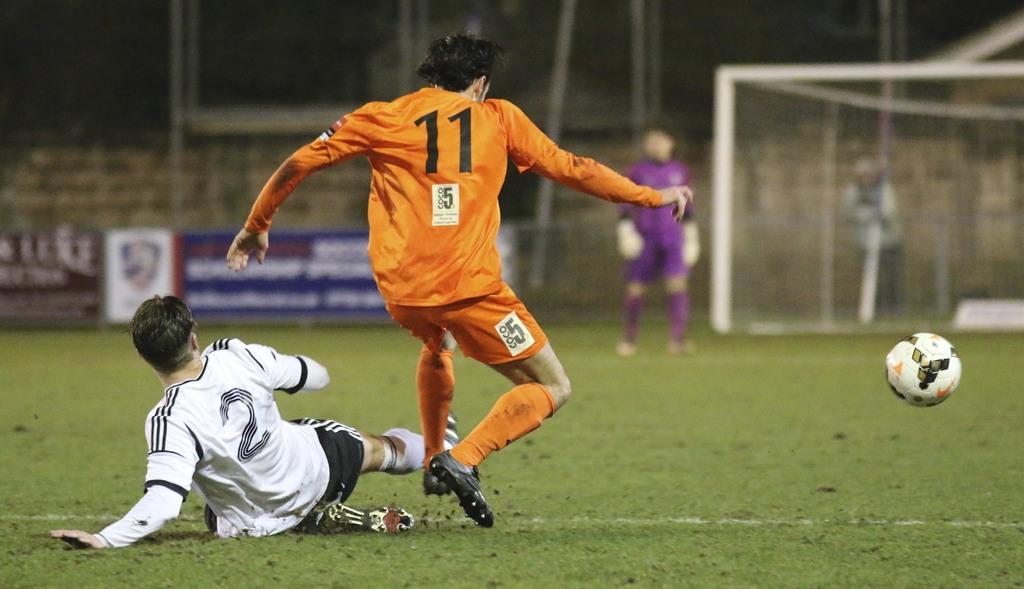What type of people can be seen in the image? There are players in the image. Where are the players located? The players are present in a playground. What object is visible in the image that is commonly used in sports? There is a ball in the image. What type of signage is present in the image? There are banners with text in the image. What type of barrier is present in the image? There is a fencing wall in the image. What type of equipment is present in the image that is used to separate areas or divide teams? There is a net in the image. How many eggs are visible in the image? There are no eggs present in the image. What type of scene is depicted in the image? The image does not depict a scene; it shows players in a playground with various sports-related objects. 